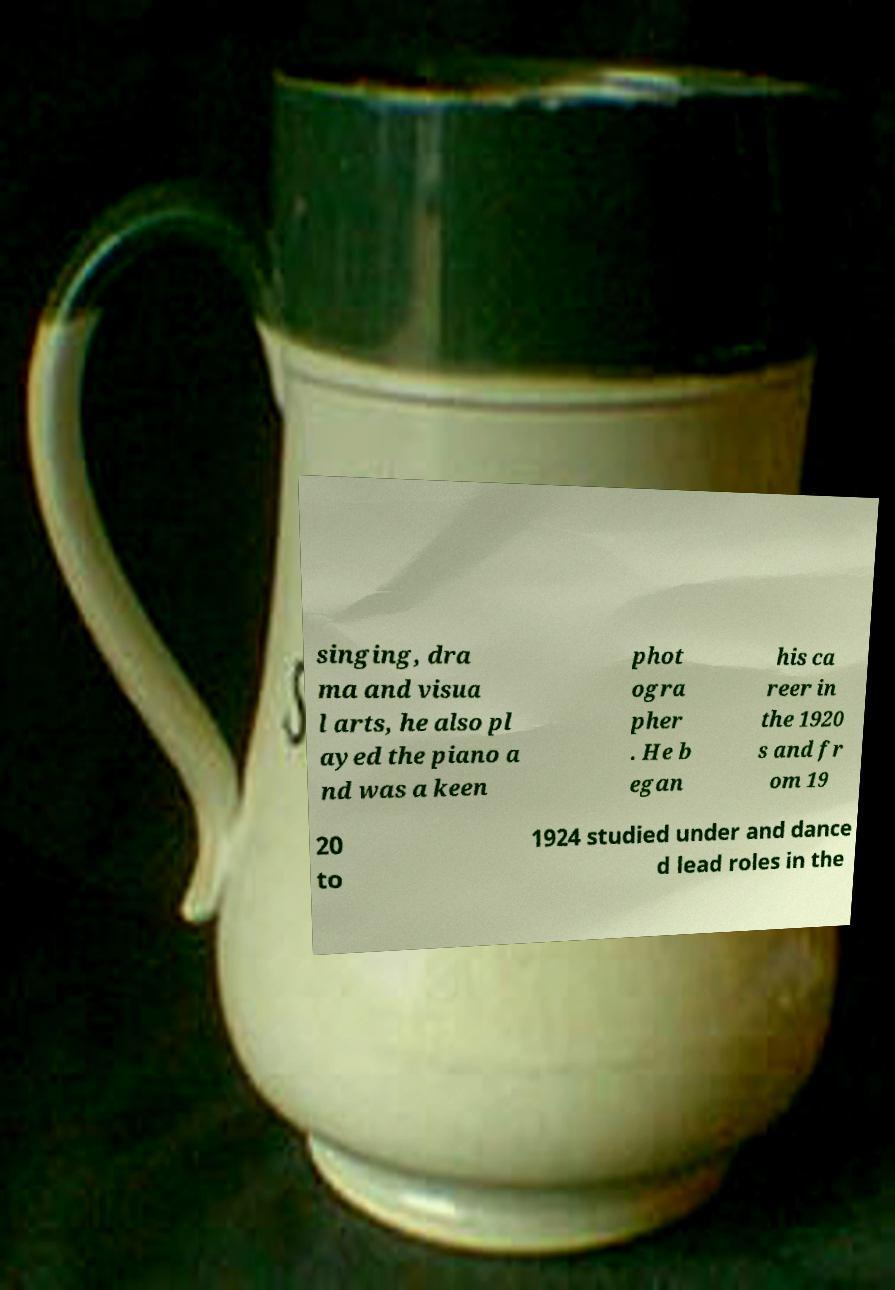Please read and relay the text visible in this image. What does it say? singing, dra ma and visua l arts, he also pl ayed the piano a nd was a keen phot ogra pher . He b egan his ca reer in the 1920 s and fr om 19 20 to 1924 studied under and dance d lead roles in the 